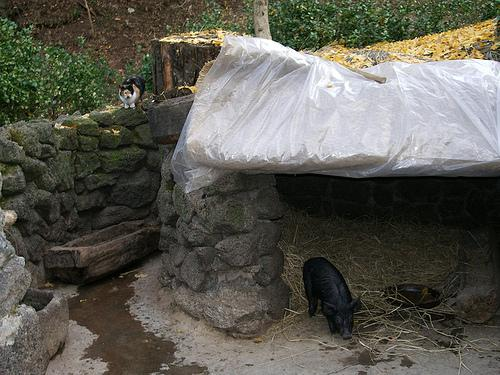Question: what is in the pig's cave?
Choices:
A. Mud.
B. Food.
C. Hay.
D. Other pigs.
Answer with the letter. Answer: C Question: what is on top of the cave?
Choices:
A. Shingles.
B. Plastic.
C. Rocks.
D. Grass.
Answer with the letter. Answer: B Question: where is the pig's food pan?
Choices:
A. On the ground.
B. By the pig.
C. In the man's hand.
D. In the cave.
Answer with the letter. Answer: D Question: what animal is in the top left corner?
Choices:
A. A dog.
B. A cat.
C. A horse.
D. A sea lion.
Answer with the letter. Answer: B 